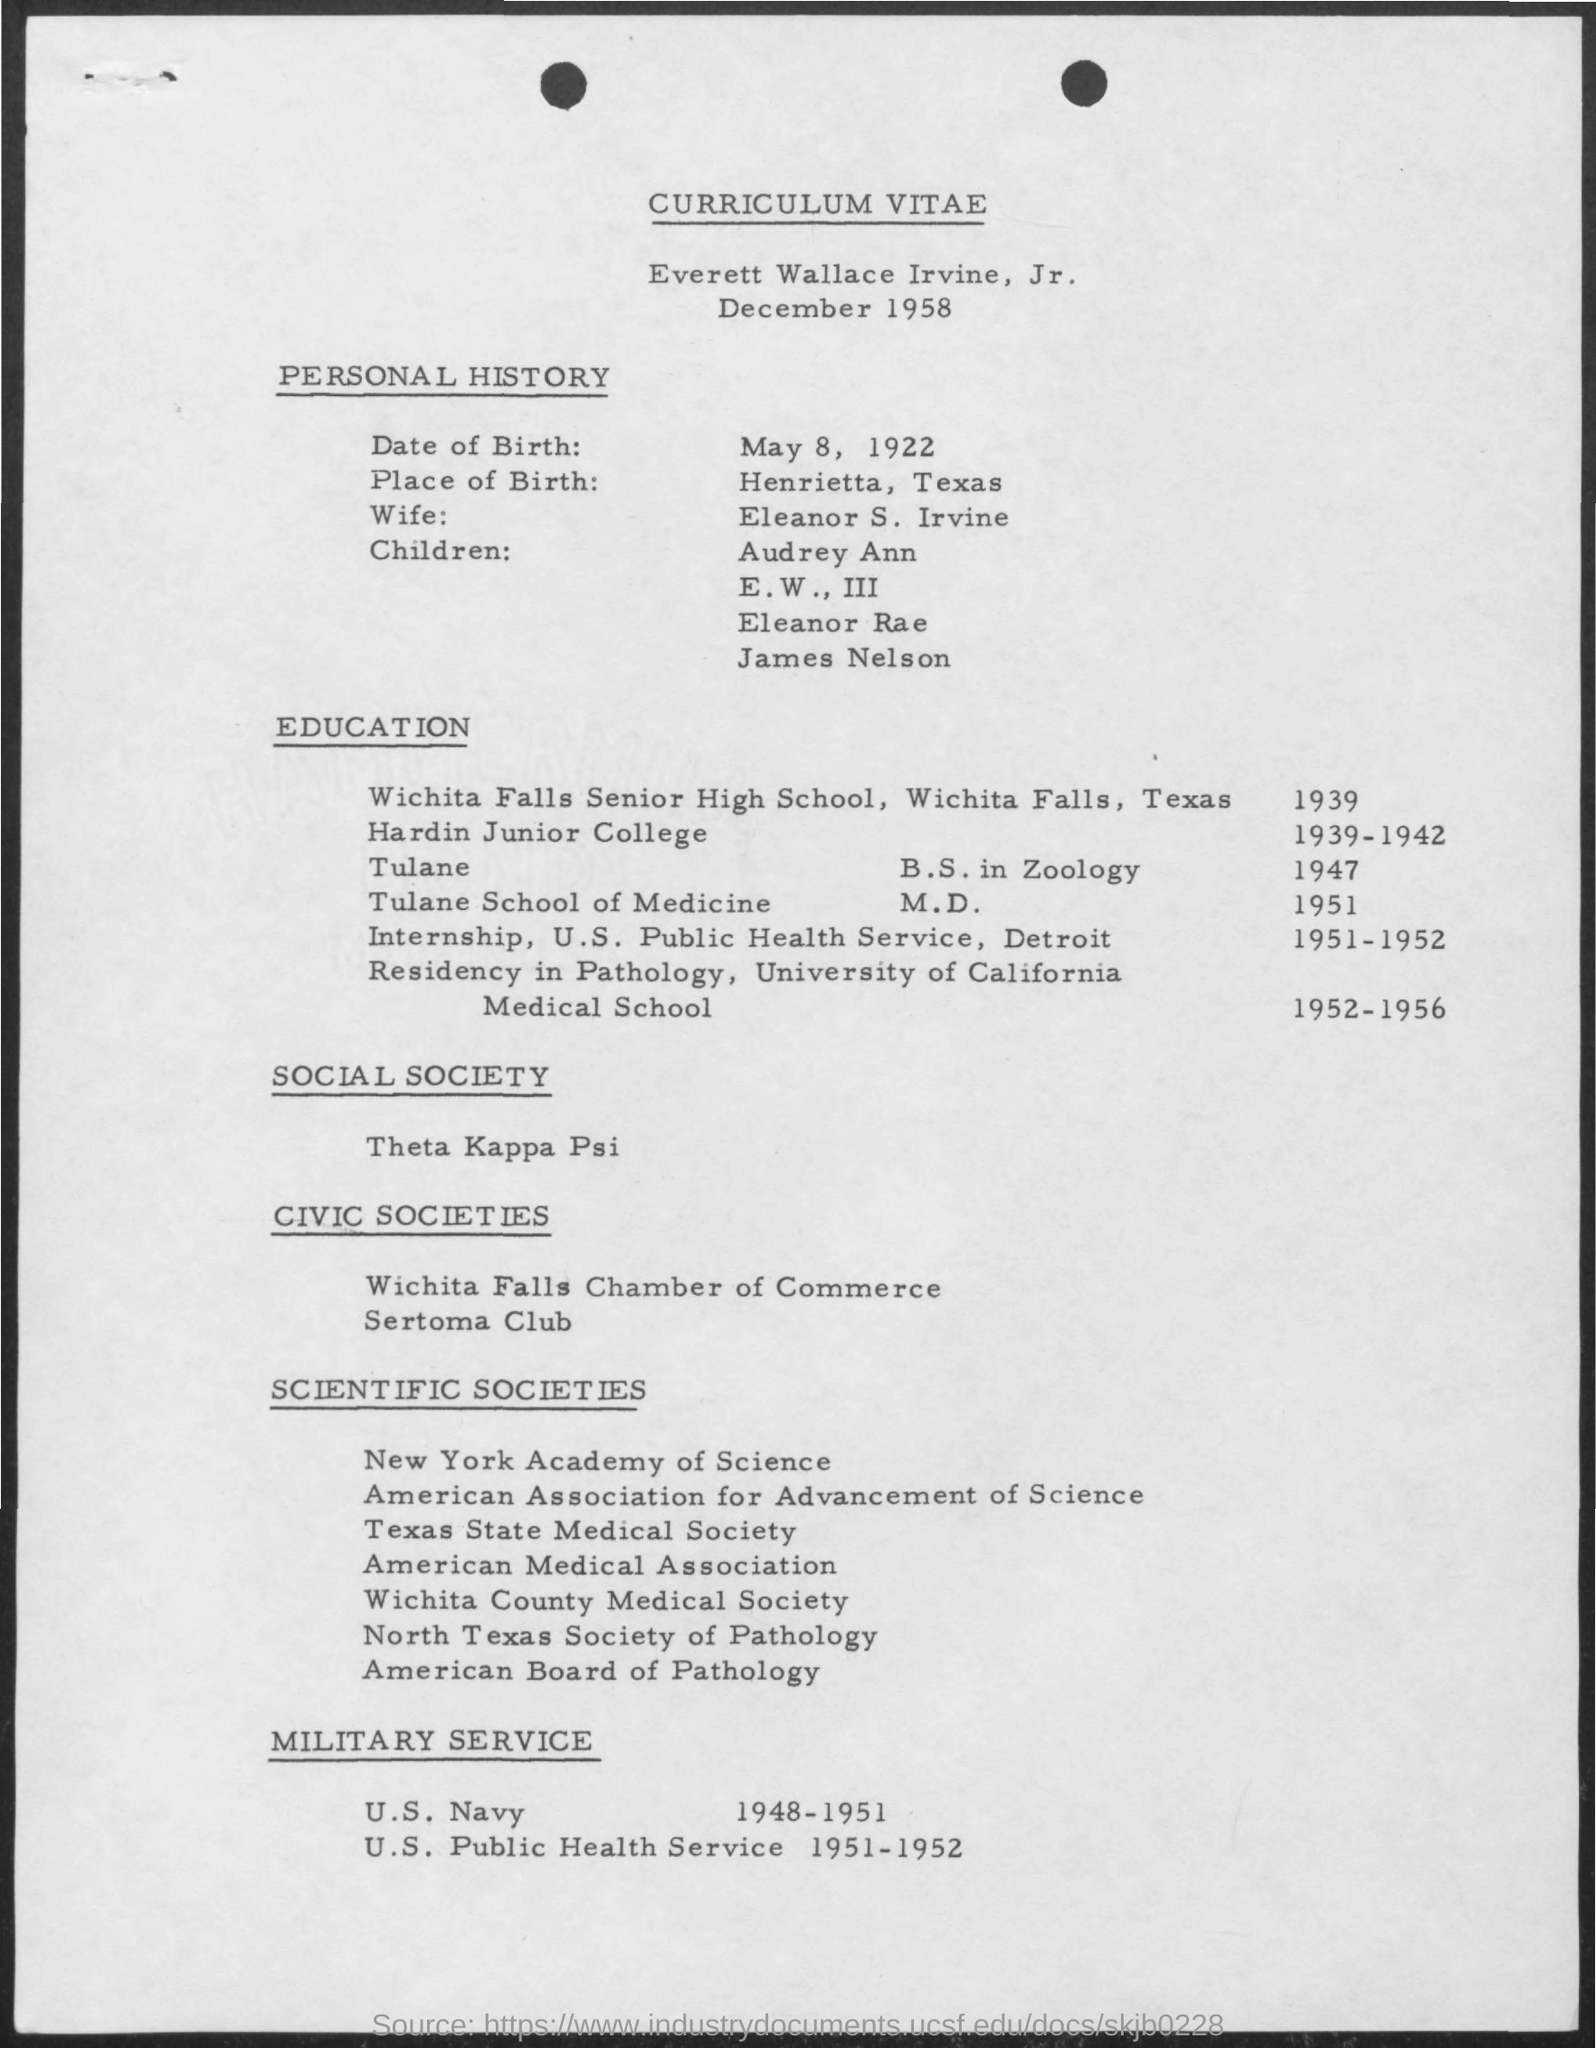Draw attention to some important aspects in this diagram. This curriculum vitae belongs to Everett Wallace Irvine, Jr. The name of the wife mentioned in the curriculum vitae is Eleanor S. Irvine. In the years 1951-1952, the individual completed their internship, as stated in their curriculum vitae. Henrietta, Texas is the place of birth mentioned in the given curriculum vitae. Everett Wallace Irvine, Jr. served in the U.S. Navy during the years 1948-1951. 